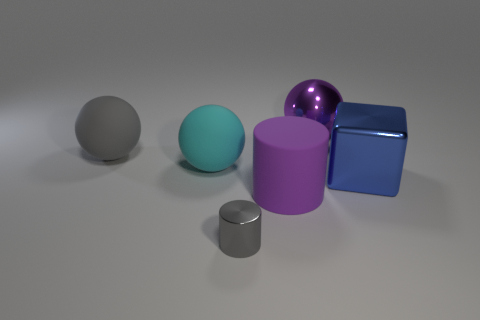Add 1 yellow spheres. How many objects exist? 7 Subtract all cubes. How many objects are left? 5 Subtract all big green matte spheres. Subtract all large balls. How many objects are left? 3 Add 4 purple cylinders. How many purple cylinders are left? 5 Add 4 blue shiny things. How many blue shiny things exist? 5 Subtract 0 red blocks. How many objects are left? 6 